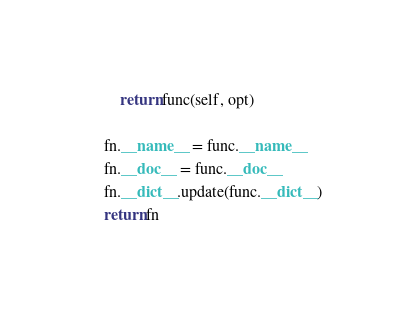Convert code to text. <code><loc_0><loc_0><loc_500><loc_500><_Python_>        return func(self, opt)

    fn.__name__ = func.__name__
    fn.__doc__ = func.__doc__
    fn.__dict__.update(func.__dict__)
    return fn
</code> 